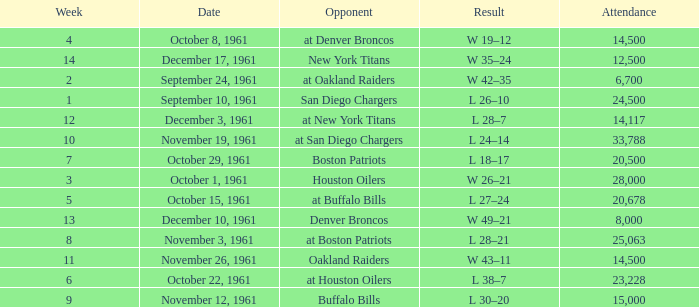What is the low week from october 15, 1961? 5.0. 